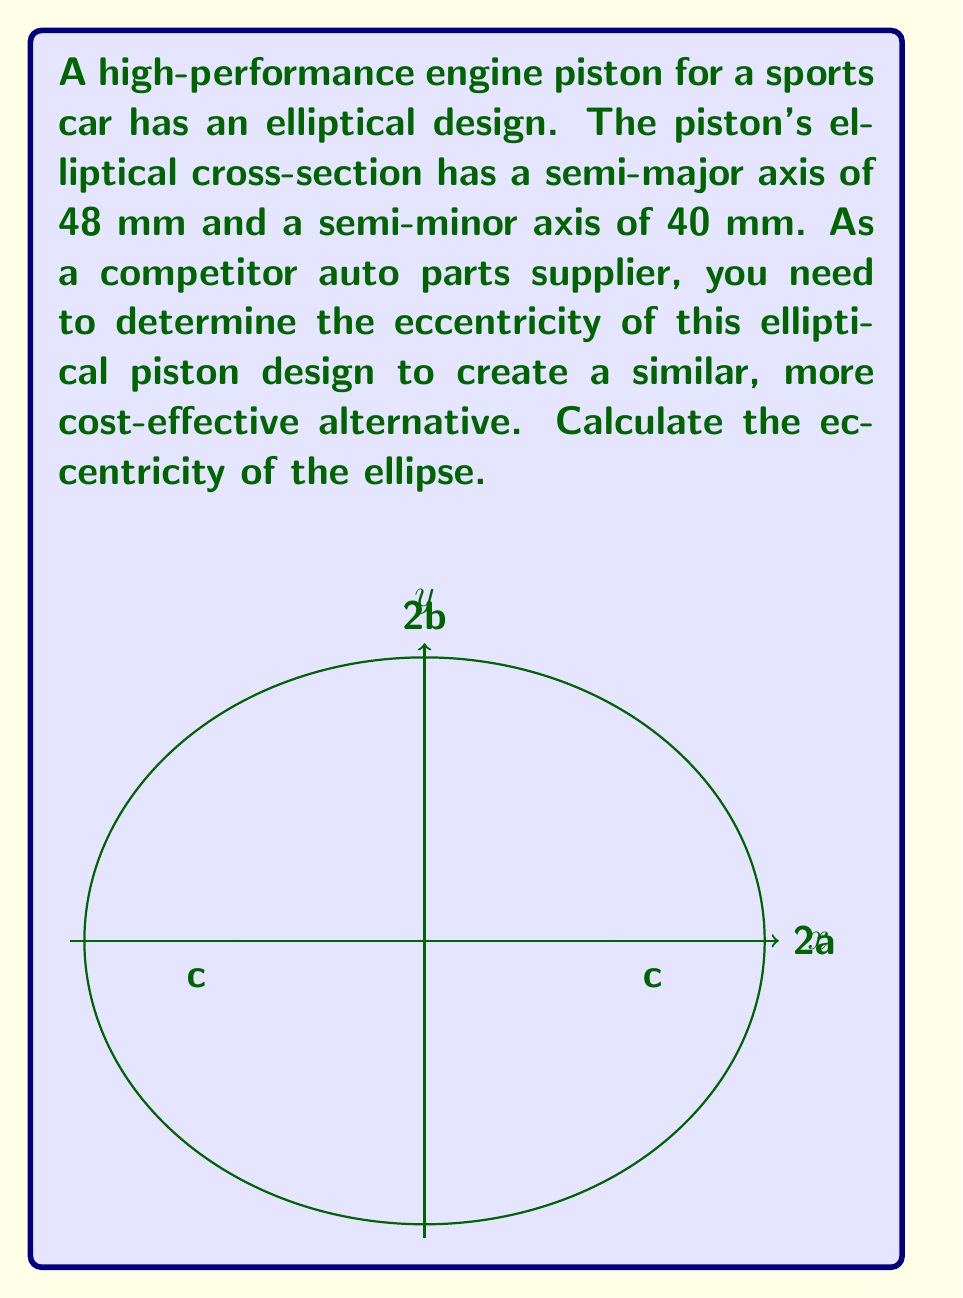Can you solve this math problem? To determine the eccentricity of an ellipse, we need to follow these steps:

1) The eccentricity (e) of an ellipse is given by the formula:

   $$e = \frac{\sqrt{a^2 - b^2}}{a}$$

   where $a$ is the semi-major axis and $b$ is the semi-minor axis.

2) We are given:
   $a = 48$ mm
   $b = 40$ mm

3) Let's substitute these values into the formula:

   $$e = \frac{\sqrt{48^2 - 40^2}}{48}$$

4) Simplify under the square root:
   
   $$e = \frac{\sqrt{2304 - 1600}}{48} = \frac{\sqrt{704}}{48}$$

5) Simplify the square root:
   
   $$e = \frac{\sqrt{16 \cdot 44}}{48} = \frac{4\sqrt{11}}{48}$$

6) Simplify the fraction:
   
   $$e = \frac{\sqrt{11}}{12}$$

This is the exact value of the eccentricity. If a decimal approximation is needed, we can calculate:

   $$e \approx 0.2764$$

The eccentricity is always a value between 0 and 1 for an ellipse, where 0 represents a circle and values closer to 1 represent more elongated ellipses.
Answer: $\frac{\sqrt{11}}{12}$ or approximately 0.2764 